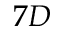Convert formula to latex. <formula><loc_0><loc_0><loc_500><loc_500>7 D</formula> 